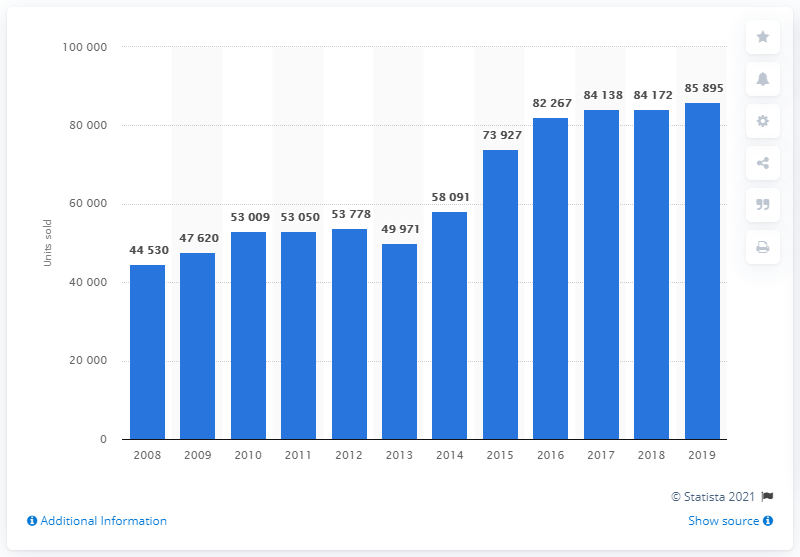Point out several critical features in this image. In 2008, a total of 44,530 Skoda cars were sold in the Czech Republic. 